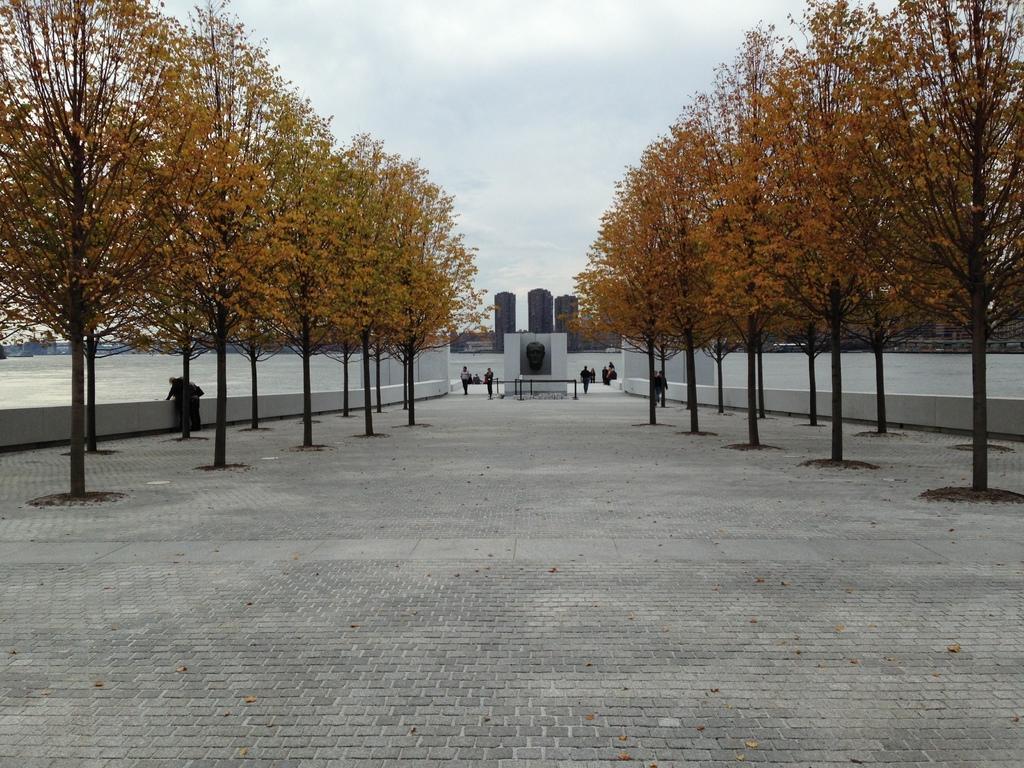Describe this image in one or two sentences. In this picture we can see a group of people where some are standing and some are walking on the ground, trees, water, buildings and in the background we can see sky with clouds. 